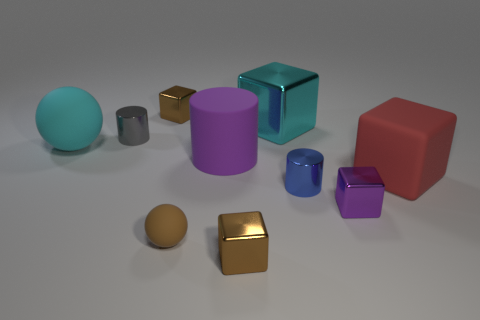What is the material of the block that is the same color as the large sphere?
Give a very brief answer. Metal. How many gray shiny things have the same shape as the large purple matte thing?
Keep it short and to the point. 1. Is the number of gray objects to the right of the purple metal object greater than the number of small gray objects?
Make the answer very short. No. What is the shape of the shiny thing right of the metallic cylinder to the right of the rubber cylinder behind the small brown rubber sphere?
Your answer should be compact. Cube. Is the shape of the small brown metal thing that is in front of the cyan matte object the same as the big cyan metal object on the left side of the tiny blue metal cylinder?
Your answer should be compact. Yes. Are there any other things that have the same size as the purple block?
Keep it short and to the point. Yes. How many cylinders are big red things or shiny things?
Give a very brief answer. 2. Is the material of the small gray thing the same as the small blue cylinder?
Give a very brief answer. Yes. How many other things are the same color as the rubber cube?
Provide a succinct answer. 0. There is a big thing that is to the left of the small gray shiny object; what is its shape?
Ensure brevity in your answer.  Sphere. 